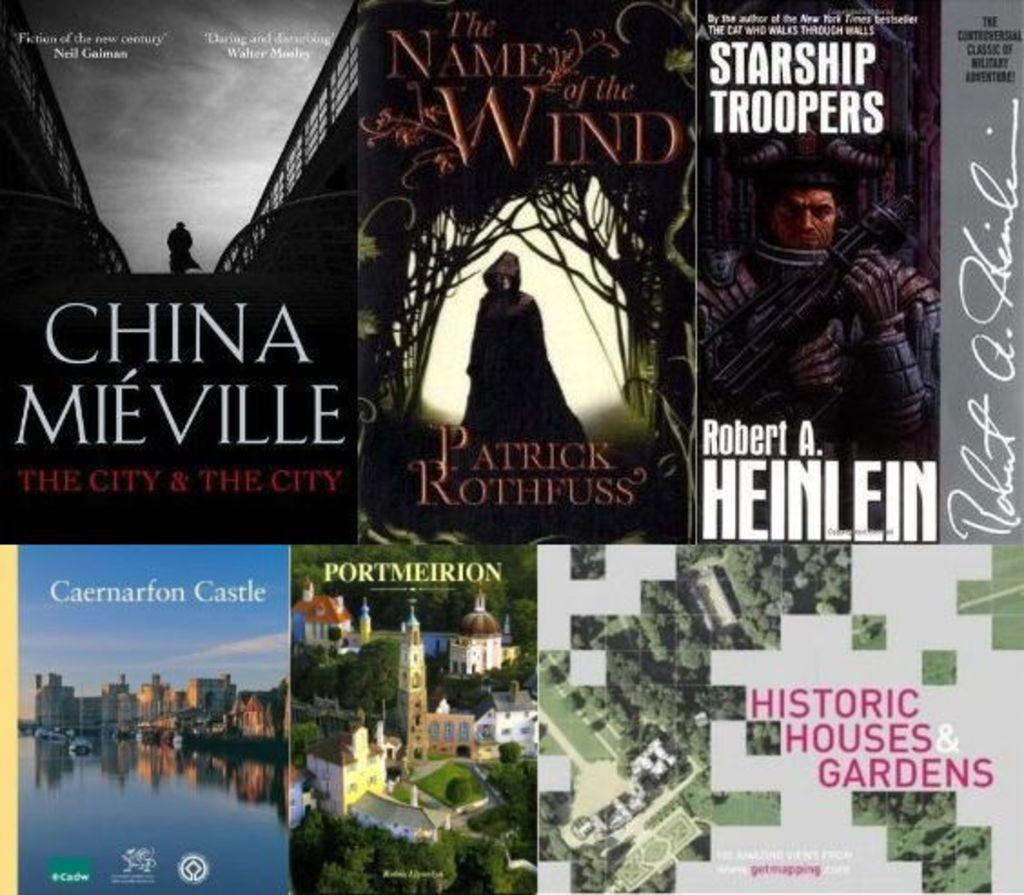<image>
Provide a brief description of the given image. A collection of books that are all set in foreign places. 